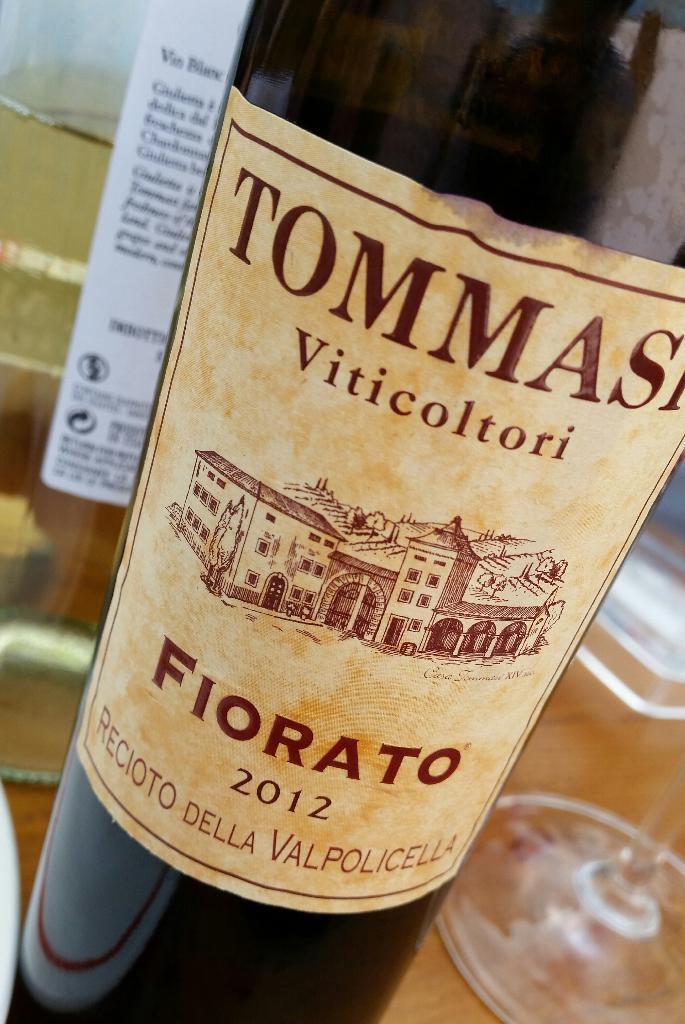<image>
Share a concise interpretation of the image provided. the word tommas that is on a wine bottle 